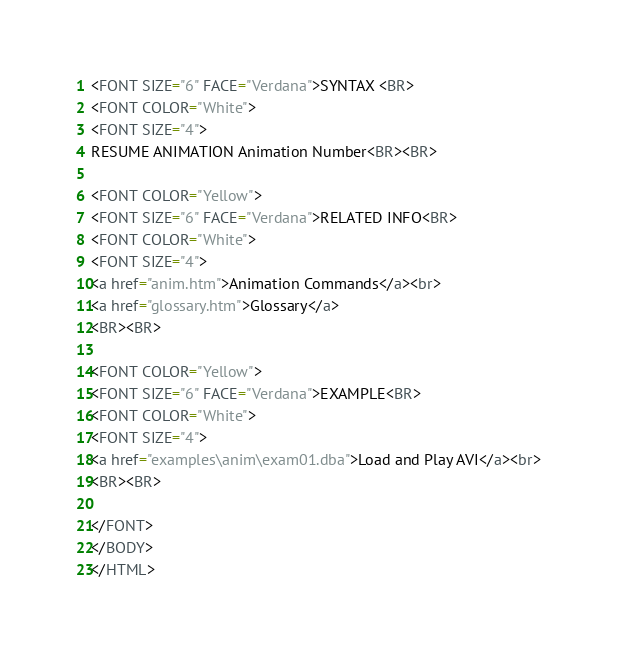<code> <loc_0><loc_0><loc_500><loc_500><_HTML_><FONT SIZE="6" FACE="Verdana">SYNTAX <BR> 
<FONT COLOR="White">
<FONT SIZE="4">
RESUME ANIMATION Animation Number<BR><BR>

<FONT COLOR="Yellow">
<FONT SIZE="6" FACE="Verdana">RELATED INFO<BR>
<FONT COLOR="White">
<FONT SIZE="4">
<a href="anim.htm">Animation Commands</a><br>
<a href="glossary.htm">Glossary</a>
<BR><BR>

<FONT COLOR="Yellow">
<FONT SIZE="6" FACE="Verdana">EXAMPLE<BR>
<FONT COLOR="White">
<FONT SIZE="4">
<a href="examples\anim\exam01.dba">Load and Play AVI</a><br>
<BR><BR>

</FONT>
</BODY>
</HTML>
</code> 